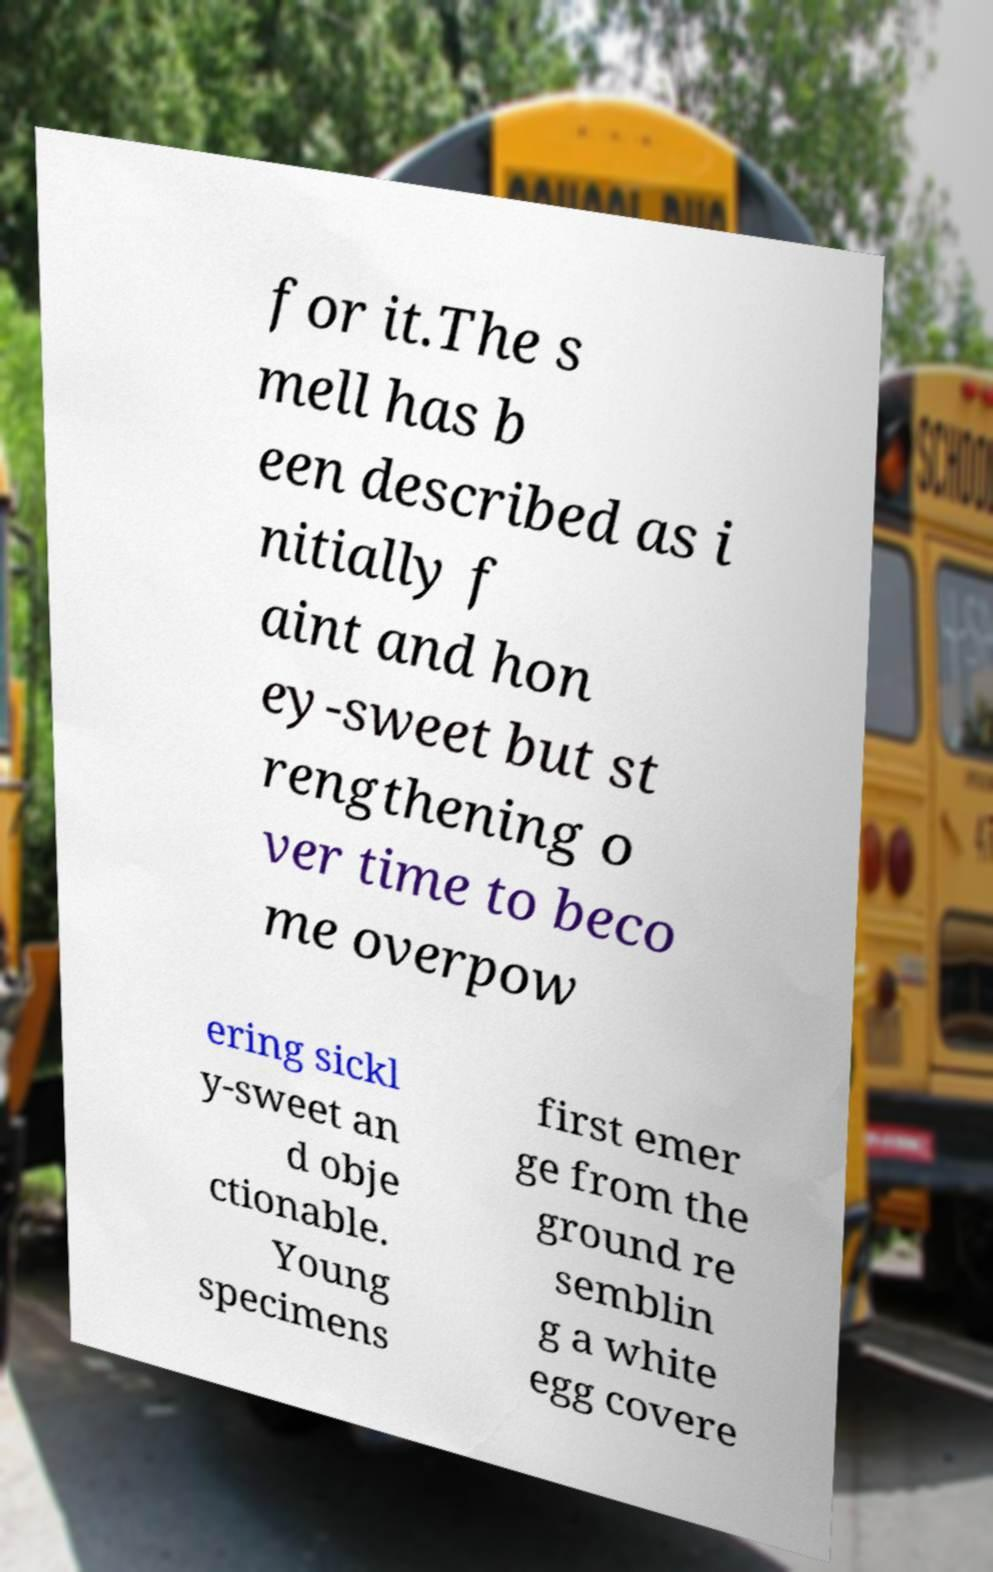Can you read and provide the text displayed in the image?This photo seems to have some interesting text. Can you extract and type it out for me? for it.The s mell has b een described as i nitially f aint and hon ey-sweet but st rengthening o ver time to beco me overpow ering sickl y-sweet an d obje ctionable. Young specimens first emer ge from the ground re semblin g a white egg covere 